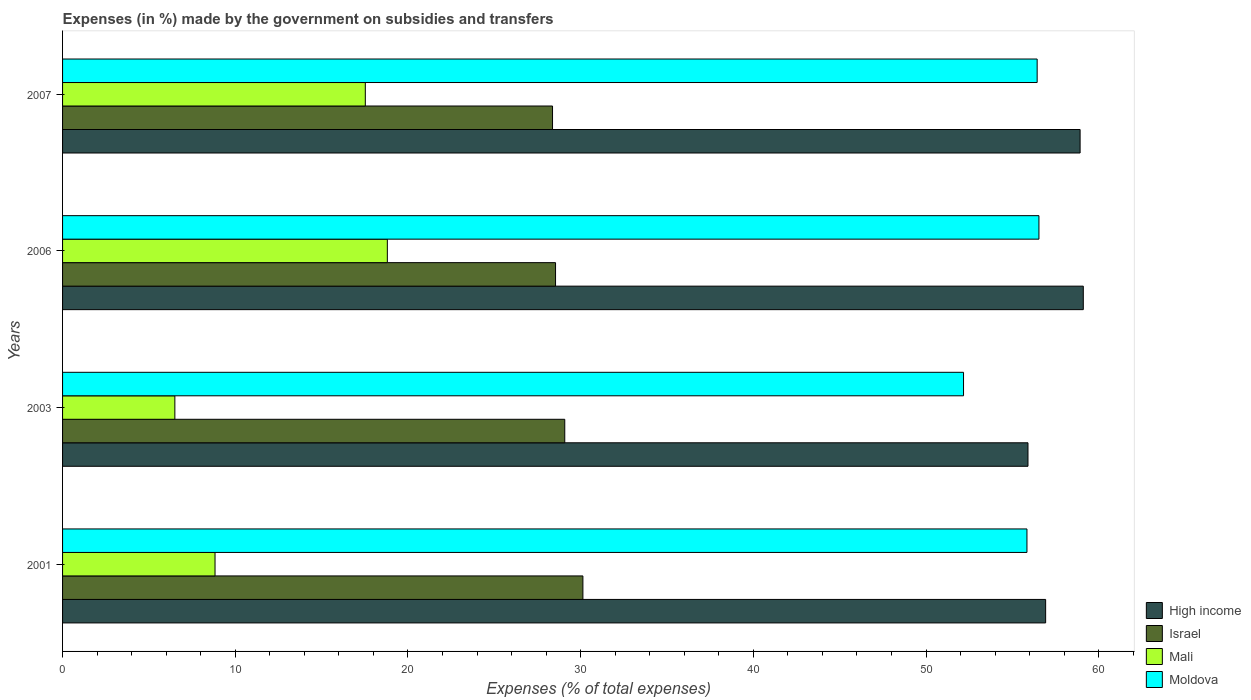How many different coloured bars are there?
Your answer should be compact. 4. How many bars are there on the 2nd tick from the bottom?
Your response must be concise. 4. What is the percentage of expenses made by the government on subsidies and transfers in Moldova in 2003?
Your answer should be very brief. 52.17. Across all years, what is the maximum percentage of expenses made by the government on subsidies and transfers in Mali?
Offer a terse response. 18.81. Across all years, what is the minimum percentage of expenses made by the government on subsidies and transfers in Moldova?
Make the answer very short. 52.17. What is the total percentage of expenses made by the government on subsidies and transfers in High income in the graph?
Make the answer very short. 230.85. What is the difference between the percentage of expenses made by the government on subsidies and transfers in Mali in 2003 and that in 2006?
Your answer should be compact. -12.3. What is the difference between the percentage of expenses made by the government on subsidies and transfers in High income in 2006 and the percentage of expenses made by the government on subsidies and transfers in Israel in 2001?
Offer a very short reply. 28.97. What is the average percentage of expenses made by the government on subsidies and transfers in Israel per year?
Your answer should be very brief. 29.03. In the year 2003, what is the difference between the percentage of expenses made by the government on subsidies and transfers in Israel and percentage of expenses made by the government on subsidies and transfers in High income?
Your response must be concise. -26.82. In how many years, is the percentage of expenses made by the government on subsidies and transfers in Moldova greater than 2 %?
Your response must be concise. 4. What is the ratio of the percentage of expenses made by the government on subsidies and transfers in Moldova in 2001 to that in 2007?
Keep it short and to the point. 0.99. Is the percentage of expenses made by the government on subsidies and transfers in Mali in 2001 less than that in 2006?
Your response must be concise. Yes. Is the difference between the percentage of expenses made by the government on subsidies and transfers in Israel in 2006 and 2007 greater than the difference between the percentage of expenses made by the government on subsidies and transfers in High income in 2006 and 2007?
Offer a terse response. No. What is the difference between the highest and the second highest percentage of expenses made by the government on subsidies and transfers in Mali?
Your answer should be compact. 1.28. What is the difference between the highest and the lowest percentage of expenses made by the government on subsidies and transfers in Mali?
Provide a succinct answer. 12.3. What does the 3rd bar from the top in 2003 represents?
Offer a very short reply. Israel. What does the 2nd bar from the bottom in 2007 represents?
Your answer should be compact. Israel. Is it the case that in every year, the sum of the percentage of expenses made by the government on subsidies and transfers in Moldova and percentage of expenses made by the government on subsidies and transfers in High income is greater than the percentage of expenses made by the government on subsidies and transfers in Israel?
Your answer should be compact. Yes. How many bars are there?
Provide a succinct answer. 16. Does the graph contain grids?
Offer a terse response. No. How many legend labels are there?
Provide a short and direct response. 4. How are the legend labels stacked?
Your response must be concise. Vertical. What is the title of the graph?
Ensure brevity in your answer.  Expenses (in %) made by the government on subsidies and transfers. Does "Cuba" appear as one of the legend labels in the graph?
Your response must be concise. No. What is the label or title of the X-axis?
Your response must be concise. Expenses (% of total expenses). What is the Expenses (% of total expenses) in High income in 2001?
Give a very brief answer. 56.92. What is the Expenses (% of total expenses) in Israel in 2001?
Keep it short and to the point. 30.13. What is the Expenses (% of total expenses) in Mali in 2001?
Make the answer very short. 8.83. What is the Expenses (% of total expenses) in Moldova in 2001?
Give a very brief answer. 55.84. What is the Expenses (% of total expenses) of High income in 2003?
Give a very brief answer. 55.9. What is the Expenses (% of total expenses) of Israel in 2003?
Ensure brevity in your answer.  29.08. What is the Expenses (% of total expenses) in Mali in 2003?
Offer a very short reply. 6.5. What is the Expenses (% of total expenses) in Moldova in 2003?
Give a very brief answer. 52.17. What is the Expenses (% of total expenses) in High income in 2006?
Provide a succinct answer. 59.1. What is the Expenses (% of total expenses) in Israel in 2006?
Keep it short and to the point. 28.55. What is the Expenses (% of total expenses) of Mali in 2006?
Offer a terse response. 18.81. What is the Expenses (% of total expenses) of Moldova in 2006?
Provide a short and direct response. 56.54. What is the Expenses (% of total expenses) in High income in 2007?
Ensure brevity in your answer.  58.92. What is the Expenses (% of total expenses) of Israel in 2007?
Your answer should be compact. 28.37. What is the Expenses (% of total expenses) in Mali in 2007?
Keep it short and to the point. 17.53. What is the Expenses (% of total expenses) of Moldova in 2007?
Keep it short and to the point. 56.43. Across all years, what is the maximum Expenses (% of total expenses) in High income?
Make the answer very short. 59.1. Across all years, what is the maximum Expenses (% of total expenses) in Israel?
Make the answer very short. 30.13. Across all years, what is the maximum Expenses (% of total expenses) in Mali?
Keep it short and to the point. 18.81. Across all years, what is the maximum Expenses (% of total expenses) in Moldova?
Give a very brief answer. 56.54. Across all years, what is the minimum Expenses (% of total expenses) of High income?
Offer a terse response. 55.9. Across all years, what is the minimum Expenses (% of total expenses) in Israel?
Provide a succinct answer. 28.37. Across all years, what is the minimum Expenses (% of total expenses) in Mali?
Your answer should be very brief. 6.5. Across all years, what is the minimum Expenses (% of total expenses) in Moldova?
Keep it short and to the point. 52.17. What is the total Expenses (% of total expenses) in High income in the graph?
Give a very brief answer. 230.85. What is the total Expenses (% of total expenses) of Israel in the graph?
Your answer should be compact. 116.12. What is the total Expenses (% of total expenses) in Mali in the graph?
Ensure brevity in your answer.  51.67. What is the total Expenses (% of total expenses) in Moldova in the graph?
Ensure brevity in your answer.  220.98. What is the difference between the Expenses (% of total expenses) in High income in 2001 and that in 2003?
Offer a very short reply. 1.02. What is the difference between the Expenses (% of total expenses) in Israel in 2001 and that in 2003?
Make the answer very short. 1.05. What is the difference between the Expenses (% of total expenses) in Mali in 2001 and that in 2003?
Keep it short and to the point. 2.33. What is the difference between the Expenses (% of total expenses) of Moldova in 2001 and that in 2003?
Keep it short and to the point. 3.67. What is the difference between the Expenses (% of total expenses) of High income in 2001 and that in 2006?
Offer a terse response. -2.18. What is the difference between the Expenses (% of total expenses) in Israel in 2001 and that in 2006?
Ensure brevity in your answer.  1.58. What is the difference between the Expenses (% of total expenses) in Mali in 2001 and that in 2006?
Give a very brief answer. -9.98. What is the difference between the Expenses (% of total expenses) of Moldova in 2001 and that in 2006?
Your response must be concise. -0.69. What is the difference between the Expenses (% of total expenses) of High income in 2001 and that in 2007?
Offer a very short reply. -2. What is the difference between the Expenses (% of total expenses) of Israel in 2001 and that in 2007?
Give a very brief answer. 1.76. What is the difference between the Expenses (% of total expenses) of Mali in 2001 and that in 2007?
Provide a short and direct response. -8.7. What is the difference between the Expenses (% of total expenses) in Moldova in 2001 and that in 2007?
Ensure brevity in your answer.  -0.59. What is the difference between the Expenses (% of total expenses) in High income in 2003 and that in 2006?
Offer a very short reply. -3.2. What is the difference between the Expenses (% of total expenses) in Israel in 2003 and that in 2006?
Your response must be concise. 0.53. What is the difference between the Expenses (% of total expenses) of Mali in 2003 and that in 2006?
Your answer should be very brief. -12.3. What is the difference between the Expenses (% of total expenses) in Moldova in 2003 and that in 2006?
Give a very brief answer. -4.37. What is the difference between the Expenses (% of total expenses) in High income in 2003 and that in 2007?
Provide a succinct answer. -3.02. What is the difference between the Expenses (% of total expenses) of Israel in 2003 and that in 2007?
Your response must be concise. 0.71. What is the difference between the Expenses (% of total expenses) of Mali in 2003 and that in 2007?
Ensure brevity in your answer.  -11.03. What is the difference between the Expenses (% of total expenses) in Moldova in 2003 and that in 2007?
Provide a succinct answer. -4.26. What is the difference between the Expenses (% of total expenses) in High income in 2006 and that in 2007?
Keep it short and to the point. 0.19. What is the difference between the Expenses (% of total expenses) of Israel in 2006 and that in 2007?
Make the answer very short. 0.17. What is the difference between the Expenses (% of total expenses) in Mali in 2006 and that in 2007?
Provide a short and direct response. 1.27. What is the difference between the Expenses (% of total expenses) in Moldova in 2006 and that in 2007?
Your answer should be compact. 0.1. What is the difference between the Expenses (% of total expenses) of High income in 2001 and the Expenses (% of total expenses) of Israel in 2003?
Ensure brevity in your answer.  27.84. What is the difference between the Expenses (% of total expenses) in High income in 2001 and the Expenses (% of total expenses) in Mali in 2003?
Your answer should be compact. 50.42. What is the difference between the Expenses (% of total expenses) of High income in 2001 and the Expenses (% of total expenses) of Moldova in 2003?
Ensure brevity in your answer.  4.75. What is the difference between the Expenses (% of total expenses) of Israel in 2001 and the Expenses (% of total expenses) of Mali in 2003?
Provide a short and direct response. 23.63. What is the difference between the Expenses (% of total expenses) in Israel in 2001 and the Expenses (% of total expenses) in Moldova in 2003?
Offer a terse response. -22.04. What is the difference between the Expenses (% of total expenses) of Mali in 2001 and the Expenses (% of total expenses) of Moldova in 2003?
Provide a succinct answer. -43.34. What is the difference between the Expenses (% of total expenses) in High income in 2001 and the Expenses (% of total expenses) in Israel in 2006?
Provide a short and direct response. 28.38. What is the difference between the Expenses (% of total expenses) in High income in 2001 and the Expenses (% of total expenses) in Mali in 2006?
Keep it short and to the point. 38.12. What is the difference between the Expenses (% of total expenses) of High income in 2001 and the Expenses (% of total expenses) of Moldova in 2006?
Ensure brevity in your answer.  0.39. What is the difference between the Expenses (% of total expenses) in Israel in 2001 and the Expenses (% of total expenses) in Mali in 2006?
Your response must be concise. 11.32. What is the difference between the Expenses (% of total expenses) of Israel in 2001 and the Expenses (% of total expenses) of Moldova in 2006?
Provide a succinct answer. -26.41. What is the difference between the Expenses (% of total expenses) of Mali in 2001 and the Expenses (% of total expenses) of Moldova in 2006?
Make the answer very short. -47.71. What is the difference between the Expenses (% of total expenses) in High income in 2001 and the Expenses (% of total expenses) in Israel in 2007?
Give a very brief answer. 28.55. What is the difference between the Expenses (% of total expenses) of High income in 2001 and the Expenses (% of total expenses) of Mali in 2007?
Offer a terse response. 39.39. What is the difference between the Expenses (% of total expenses) in High income in 2001 and the Expenses (% of total expenses) in Moldova in 2007?
Provide a short and direct response. 0.49. What is the difference between the Expenses (% of total expenses) of Israel in 2001 and the Expenses (% of total expenses) of Mali in 2007?
Provide a succinct answer. 12.6. What is the difference between the Expenses (% of total expenses) in Israel in 2001 and the Expenses (% of total expenses) in Moldova in 2007?
Ensure brevity in your answer.  -26.3. What is the difference between the Expenses (% of total expenses) of Mali in 2001 and the Expenses (% of total expenses) of Moldova in 2007?
Make the answer very short. -47.6. What is the difference between the Expenses (% of total expenses) in High income in 2003 and the Expenses (% of total expenses) in Israel in 2006?
Your answer should be compact. 27.36. What is the difference between the Expenses (% of total expenses) of High income in 2003 and the Expenses (% of total expenses) of Mali in 2006?
Offer a terse response. 37.1. What is the difference between the Expenses (% of total expenses) of High income in 2003 and the Expenses (% of total expenses) of Moldova in 2006?
Provide a short and direct response. -0.63. What is the difference between the Expenses (% of total expenses) of Israel in 2003 and the Expenses (% of total expenses) of Mali in 2006?
Your answer should be very brief. 10.27. What is the difference between the Expenses (% of total expenses) of Israel in 2003 and the Expenses (% of total expenses) of Moldova in 2006?
Your answer should be compact. -27.46. What is the difference between the Expenses (% of total expenses) in Mali in 2003 and the Expenses (% of total expenses) in Moldova in 2006?
Make the answer very short. -50.03. What is the difference between the Expenses (% of total expenses) in High income in 2003 and the Expenses (% of total expenses) in Israel in 2007?
Offer a very short reply. 27.53. What is the difference between the Expenses (% of total expenses) of High income in 2003 and the Expenses (% of total expenses) of Mali in 2007?
Provide a succinct answer. 38.37. What is the difference between the Expenses (% of total expenses) in High income in 2003 and the Expenses (% of total expenses) in Moldova in 2007?
Offer a terse response. -0.53. What is the difference between the Expenses (% of total expenses) in Israel in 2003 and the Expenses (% of total expenses) in Mali in 2007?
Provide a succinct answer. 11.55. What is the difference between the Expenses (% of total expenses) in Israel in 2003 and the Expenses (% of total expenses) in Moldova in 2007?
Ensure brevity in your answer.  -27.35. What is the difference between the Expenses (% of total expenses) of Mali in 2003 and the Expenses (% of total expenses) of Moldova in 2007?
Make the answer very short. -49.93. What is the difference between the Expenses (% of total expenses) of High income in 2006 and the Expenses (% of total expenses) of Israel in 2007?
Provide a succinct answer. 30.73. What is the difference between the Expenses (% of total expenses) in High income in 2006 and the Expenses (% of total expenses) in Mali in 2007?
Your answer should be compact. 41.57. What is the difference between the Expenses (% of total expenses) of High income in 2006 and the Expenses (% of total expenses) of Moldova in 2007?
Your response must be concise. 2.67. What is the difference between the Expenses (% of total expenses) of Israel in 2006 and the Expenses (% of total expenses) of Mali in 2007?
Your response must be concise. 11.01. What is the difference between the Expenses (% of total expenses) in Israel in 2006 and the Expenses (% of total expenses) in Moldova in 2007?
Your response must be concise. -27.89. What is the difference between the Expenses (% of total expenses) in Mali in 2006 and the Expenses (% of total expenses) in Moldova in 2007?
Your answer should be very brief. -37.63. What is the average Expenses (% of total expenses) in High income per year?
Offer a terse response. 57.71. What is the average Expenses (% of total expenses) of Israel per year?
Offer a very short reply. 29.03. What is the average Expenses (% of total expenses) of Mali per year?
Your answer should be compact. 12.92. What is the average Expenses (% of total expenses) of Moldova per year?
Give a very brief answer. 55.24. In the year 2001, what is the difference between the Expenses (% of total expenses) of High income and Expenses (% of total expenses) of Israel?
Your answer should be very brief. 26.79. In the year 2001, what is the difference between the Expenses (% of total expenses) of High income and Expenses (% of total expenses) of Mali?
Offer a very short reply. 48.09. In the year 2001, what is the difference between the Expenses (% of total expenses) of High income and Expenses (% of total expenses) of Moldova?
Offer a terse response. 1.08. In the year 2001, what is the difference between the Expenses (% of total expenses) in Israel and Expenses (% of total expenses) in Mali?
Provide a succinct answer. 21.3. In the year 2001, what is the difference between the Expenses (% of total expenses) in Israel and Expenses (% of total expenses) in Moldova?
Make the answer very short. -25.71. In the year 2001, what is the difference between the Expenses (% of total expenses) in Mali and Expenses (% of total expenses) in Moldova?
Give a very brief answer. -47.01. In the year 2003, what is the difference between the Expenses (% of total expenses) in High income and Expenses (% of total expenses) in Israel?
Give a very brief answer. 26.82. In the year 2003, what is the difference between the Expenses (% of total expenses) in High income and Expenses (% of total expenses) in Mali?
Provide a succinct answer. 49.4. In the year 2003, what is the difference between the Expenses (% of total expenses) in High income and Expenses (% of total expenses) in Moldova?
Provide a short and direct response. 3.73. In the year 2003, what is the difference between the Expenses (% of total expenses) in Israel and Expenses (% of total expenses) in Mali?
Offer a very short reply. 22.58. In the year 2003, what is the difference between the Expenses (% of total expenses) of Israel and Expenses (% of total expenses) of Moldova?
Provide a succinct answer. -23.09. In the year 2003, what is the difference between the Expenses (% of total expenses) in Mali and Expenses (% of total expenses) in Moldova?
Give a very brief answer. -45.67. In the year 2006, what is the difference between the Expenses (% of total expenses) of High income and Expenses (% of total expenses) of Israel?
Make the answer very short. 30.56. In the year 2006, what is the difference between the Expenses (% of total expenses) in High income and Expenses (% of total expenses) in Mali?
Your response must be concise. 40.3. In the year 2006, what is the difference between the Expenses (% of total expenses) of High income and Expenses (% of total expenses) of Moldova?
Your answer should be very brief. 2.57. In the year 2006, what is the difference between the Expenses (% of total expenses) in Israel and Expenses (% of total expenses) in Mali?
Your answer should be very brief. 9.74. In the year 2006, what is the difference between the Expenses (% of total expenses) in Israel and Expenses (% of total expenses) in Moldova?
Ensure brevity in your answer.  -27.99. In the year 2006, what is the difference between the Expenses (% of total expenses) of Mali and Expenses (% of total expenses) of Moldova?
Keep it short and to the point. -37.73. In the year 2007, what is the difference between the Expenses (% of total expenses) in High income and Expenses (% of total expenses) in Israel?
Provide a succinct answer. 30.55. In the year 2007, what is the difference between the Expenses (% of total expenses) in High income and Expenses (% of total expenses) in Mali?
Provide a short and direct response. 41.39. In the year 2007, what is the difference between the Expenses (% of total expenses) in High income and Expenses (% of total expenses) in Moldova?
Provide a short and direct response. 2.49. In the year 2007, what is the difference between the Expenses (% of total expenses) in Israel and Expenses (% of total expenses) in Mali?
Ensure brevity in your answer.  10.84. In the year 2007, what is the difference between the Expenses (% of total expenses) in Israel and Expenses (% of total expenses) in Moldova?
Your answer should be compact. -28.06. In the year 2007, what is the difference between the Expenses (% of total expenses) of Mali and Expenses (% of total expenses) of Moldova?
Your answer should be compact. -38.9. What is the ratio of the Expenses (% of total expenses) of High income in 2001 to that in 2003?
Your answer should be very brief. 1.02. What is the ratio of the Expenses (% of total expenses) of Israel in 2001 to that in 2003?
Provide a succinct answer. 1.04. What is the ratio of the Expenses (% of total expenses) of Mali in 2001 to that in 2003?
Your response must be concise. 1.36. What is the ratio of the Expenses (% of total expenses) in Moldova in 2001 to that in 2003?
Make the answer very short. 1.07. What is the ratio of the Expenses (% of total expenses) in High income in 2001 to that in 2006?
Give a very brief answer. 0.96. What is the ratio of the Expenses (% of total expenses) in Israel in 2001 to that in 2006?
Your answer should be very brief. 1.06. What is the ratio of the Expenses (% of total expenses) of Mali in 2001 to that in 2006?
Keep it short and to the point. 0.47. What is the ratio of the Expenses (% of total expenses) of Moldova in 2001 to that in 2006?
Your response must be concise. 0.99. What is the ratio of the Expenses (% of total expenses) in High income in 2001 to that in 2007?
Provide a succinct answer. 0.97. What is the ratio of the Expenses (% of total expenses) in Israel in 2001 to that in 2007?
Your answer should be very brief. 1.06. What is the ratio of the Expenses (% of total expenses) in Mali in 2001 to that in 2007?
Ensure brevity in your answer.  0.5. What is the ratio of the Expenses (% of total expenses) in Moldova in 2001 to that in 2007?
Offer a terse response. 0.99. What is the ratio of the Expenses (% of total expenses) of High income in 2003 to that in 2006?
Your answer should be compact. 0.95. What is the ratio of the Expenses (% of total expenses) in Israel in 2003 to that in 2006?
Provide a succinct answer. 1.02. What is the ratio of the Expenses (% of total expenses) of Mali in 2003 to that in 2006?
Provide a succinct answer. 0.35. What is the ratio of the Expenses (% of total expenses) of Moldova in 2003 to that in 2006?
Ensure brevity in your answer.  0.92. What is the ratio of the Expenses (% of total expenses) of High income in 2003 to that in 2007?
Keep it short and to the point. 0.95. What is the ratio of the Expenses (% of total expenses) of Israel in 2003 to that in 2007?
Offer a very short reply. 1.02. What is the ratio of the Expenses (% of total expenses) of Mali in 2003 to that in 2007?
Ensure brevity in your answer.  0.37. What is the ratio of the Expenses (% of total expenses) in Moldova in 2003 to that in 2007?
Make the answer very short. 0.92. What is the ratio of the Expenses (% of total expenses) in Mali in 2006 to that in 2007?
Give a very brief answer. 1.07. What is the ratio of the Expenses (% of total expenses) of Moldova in 2006 to that in 2007?
Offer a terse response. 1. What is the difference between the highest and the second highest Expenses (% of total expenses) of High income?
Your answer should be compact. 0.19. What is the difference between the highest and the second highest Expenses (% of total expenses) in Israel?
Your response must be concise. 1.05. What is the difference between the highest and the second highest Expenses (% of total expenses) of Mali?
Keep it short and to the point. 1.27. What is the difference between the highest and the second highest Expenses (% of total expenses) in Moldova?
Keep it short and to the point. 0.1. What is the difference between the highest and the lowest Expenses (% of total expenses) in High income?
Your answer should be very brief. 3.2. What is the difference between the highest and the lowest Expenses (% of total expenses) of Israel?
Provide a succinct answer. 1.76. What is the difference between the highest and the lowest Expenses (% of total expenses) in Mali?
Keep it short and to the point. 12.3. What is the difference between the highest and the lowest Expenses (% of total expenses) of Moldova?
Give a very brief answer. 4.37. 